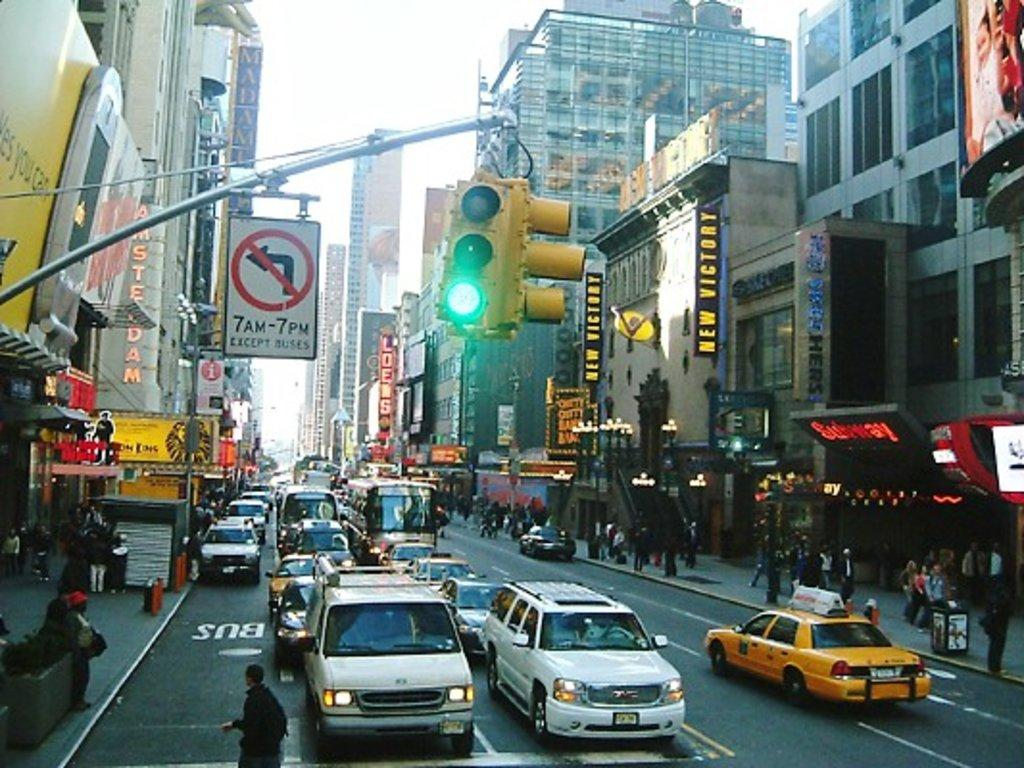<image>
Describe the image concisely. The sign on the left states that there is no left turn from 7am to 7pm except for buses. 